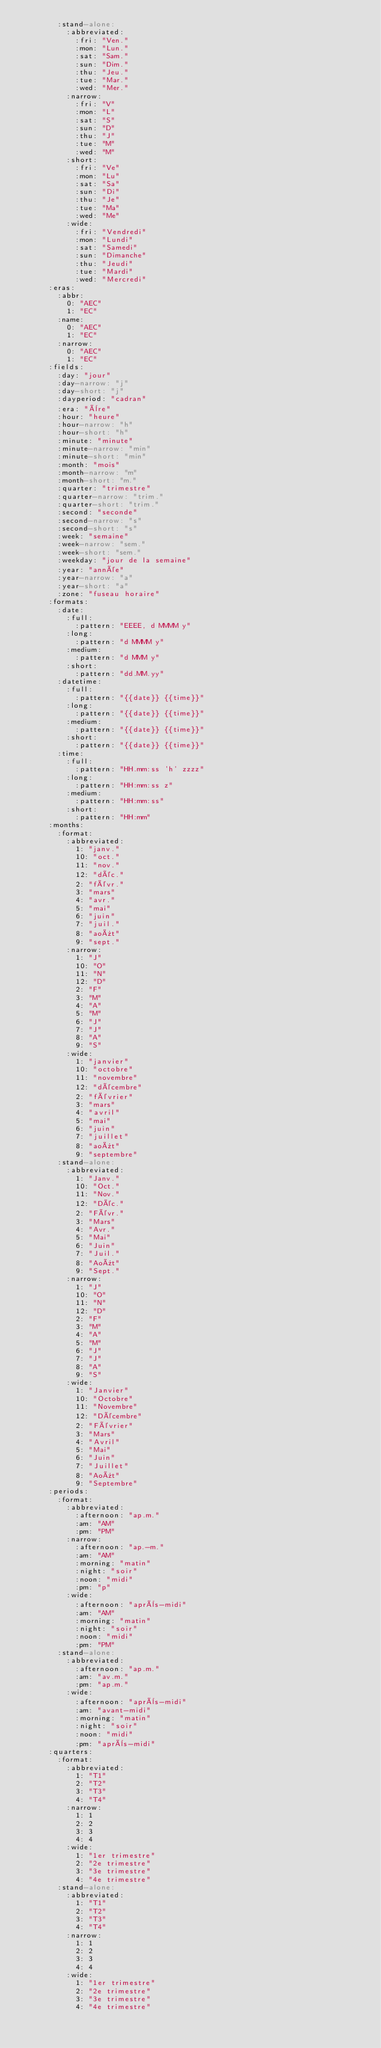<code> <loc_0><loc_0><loc_500><loc_500><_YAML_>        :stand-alone: 
          :abbreviated: 
            :fri: "Ven."
            :mon: "Lun."
            :sat: "Sam."
            :sun: "Dim."
            :thu: "Jeu."
            :tue: "Mar."
            :wed: "Mer."
          :narrow: 
            :fri: "V"
            :mon: "L"
            :sat: "S"
            :sun: "D"
            :thu: "J"
            :tue: "M"
            :wed: "M"
          :short: 
            :fri: "Ve"
            :mon: "Lu"
            :sat: "Sa"
            :sun: "Di"
            :thu: "Je"
            :tue: "Ma"
            :wed: "Me"
          :wide: 
            :fri: "Vendredi"
            :mon: "Lundi"
            :sat: "Samedi"
            :sun: "Dimanche"
            :thu: "Jeudi"
            :tue: "Mardi"
            :wed: "Mercredi"
      :eras: 
        :abbr: 
          0: "AEC"
          1: "EC"
        :name: 
          0: "AEC"
          1: "EC"
        :narrow: 
          0: "AEC"
          1: "EC"
      :fields: 
        :day: "jour"
        :day-narrow: "j"
        :day-short: "j"
        :dayperiod: "cadran"
        :era: "ère"
        :hour: "heure"
        :hour-narrow: "h"
        :hour-short: "h"
        :minute: "minute"
        :minute-narrow: "min"
        :minute-short: "min"
        :month: "mois"
        :month-narrow: "m"
        :month-short: "m."
        :quarter: "trimestre"
        :quarter-narrow: "trim."
        :quarter-short: "trim."
        :second: "seconde"
        :second-narrow: "s"
        :second-short: "s"
        :week: "semaine"
        :week-narrow: "sem."
        :week-short: "sem."
        :weekday: "jour de la semaine"
        :year: "année"
        :year-narrow: "a"
        :year-short: "a"
        :zone: "fuseau horaire"
      :formats: 
        :date: 
          :full: 
            :pattern: "EEEE, d MMMM y"
          :long: 
            :pattern: "d MMMM y"
          :medium: 
            :pattern: "d MMM y"
          :short: 
            :pattern: "dd.MM.yy"
        :datetime: 
          :full: 
            :pattern: "{{date}} {{time}}"
          :long: 
            :pattern: "{{date}} {{time}}"
          :medium: 
            :pattern: "{{date}} {{time}}"
          :short: 
            :pattern: "{{date}} {{time}}"
        :time: 
          :full: 
            :pattern: "HH.mm:ss 'h' zzzz"
          :long: 
            :pattern: "HH:mm:ss z"
          :medium: 
            :pattern: "HH:mm:ss"
          :short: 
            :pattern: "HH:mm"
      :months: 
        :format: 
          :abbreviated: 
            1: "janv."
            10: "oct."
            11: "nov."
            12: "déc."
            2: "févr."
            3: "mars"
            4: "avr."
            5: "mai"
            6: "juin"
            7: "juil."
            8: "août"
            9: "sept."
          :narrow: 
            1: "J"
            10: "O"
            11: "N"
            12: "D"
            2: "F"
            3: "M"
            4: "A"
            5: "M"
            6: "J"
            7: "J"
            8: "A"
            9: "S"
          :wide: 
            1: "janvier"
            10: "octobre"
            11: "novembre"
            12: "décembre"
            2: "février"
            3: "mars"
            4: "avril"
            5: "mai"
            6: "juin"
            7: "juillet"
            8: "août"
            9: "septembre"
        :stand-alone: 
          :abbreviated: 
            1: "Janv."
            10: "Oct."
            11: "Nov."
            12: "Déc."
            2: "Févr."
            3: "Mars"
            4: "Avr."
            5: "Mai"
            6: "Juin"
            7: "Juil."
            8: "Août"
            9: "Sept."
          :narrow: 
            1: "J"
            10: "O"
            11: "N"
            12: "D"
            2: "F"
            3: "M"
            4: "A"
            5: "M"
            6: "J"
            7: "J"
            8: "A"
            9: "S"
          :wide: 
            1: "Janvier"
            10: "Octobre"
            11: "Novembre"
            12: "Décembre"
            2: "Février"
            3: "Mars"
            4: "Avril"
            5: "Mai"
            6: "Juin"
            7: "Juillet"
            8: "Août"
            9: "Septembre"
      :periods: 
        :format: 
          :abbreviated: 
            :afternoon: "ap.m."
            :am: "AM"
            :pm: "PM"
          :narrow: 
            :afternoon: "ap.-m."
            :am: "AM"
            :morning: "matin"
            :night: "soir"
            :noon: "midi"
            :pm: "p"
          :wide: 
            :afternoon: "après-midi"
            :am: "AM"
            :morning: "matin"
            :night: "soir"
            :noon: "midi"
            :pm: "PM"
        :stand-alone: 
          :abbreviated: 
            :afternoon: "ap.m."
            :am: "av.m."
            :pm: "ap.m."
          :wide: 
            :afternoon: "après-midi"
            :am: "avant-midi"
            :morning: "matin"
            :night: "soir"
            :noon: "midi"
            :pm: "après-midi"
      :quarters: 
        :format: 
          :abbreviated: 
            1: "T1"
            2: "T2"
            3: "T3"
            4: "T4"
          :narrow: 
            1: 1
            2: 2
            3: 3
            4: 4
          :wide: 
            1: "1er trimestre"
            2: "2e trimestre"
            3: "3e trimestre"
            4: "4e trimestre"
        :stand-alone: 
          :abbreviated: 
            1: "T1"
            2: "T2"
            3: "T3"
            4: "T4"
          :narrow: 
            1: 1
            2: 2
            3: 3
            4: 4
          :wide: 
            1: "1er trimestre"
            2: "2e trimestre"
            3: "3e trimestre"
            4: "4e trimestre"
</code> 